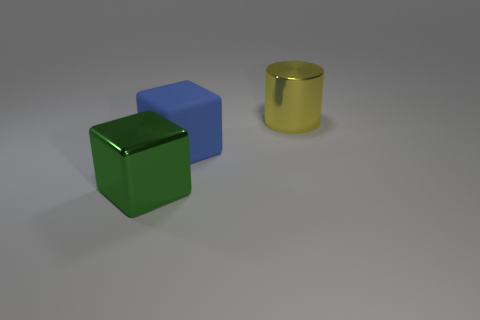What number of objects are shiny objects to the left of the yellow cylinder or tiny balls?
Offer a very short reply. 1. What is the color of the big cube to the right of the cube left of the big block that is to the right of the green block?
Provide a succinct answer. Blue. There is a large cube that is made of the same material as the big yellow cylinder; what color is it?
Offer a very short reply. Green. How many other large objects have the same material as the yellow thing?
Provide a succinct answer. 1. Does the block in front of the rubber object have the same size as the blue block?
Offer a terse response. Yes. What is the color of the cylinder that is the same size as the matte block?
Your answer should be compact. Yellow. There is a large green metallic thing; what number of big blue rubber cubes are behind it?
Offer a terse response. 1. Are there any big red matte balls?
Provide a succinct answer. No. What is the size of the shiny object in front of the big block that is to the right of the big shiny thing that is left of the cylinder?
Provide a succinct answer. Large. What number of other things are the same size as the yellow object?
Your response must be concise. 2. 